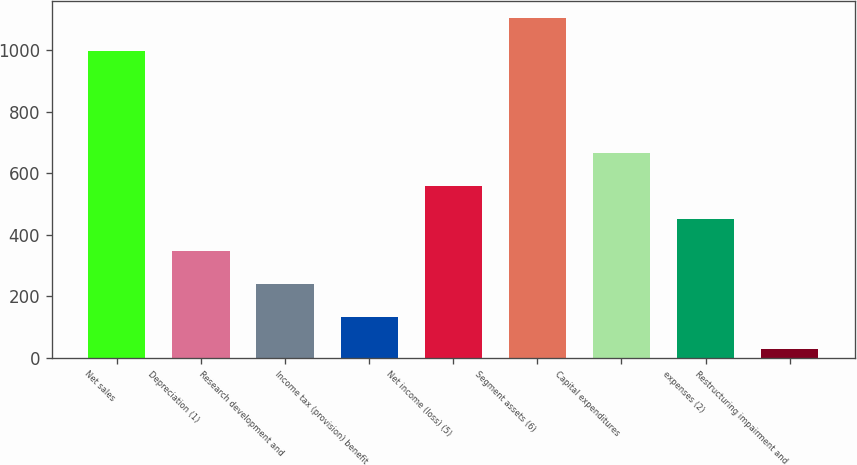<chart> <loc_0><loc_0><loc_500><loc_500><bar_chart><fcel>Net sales<fcel>Depreciation (1)<fcel>Research development and<fcel>Income tax (provision) benefit<fcel>Net income (loss) (5)<fcel>Segment assets (6)<fcel>Capital expenditures<fcel>expenses (2)<fcel>Restructuring impairment and<nl><fcel>998<fcel>346.3<fcel>240.2<fcel>134.1<fcel>558.5<fcel>1104.1<fcel>664.6<fcel>452.4<fcel>28<nl></chart> 